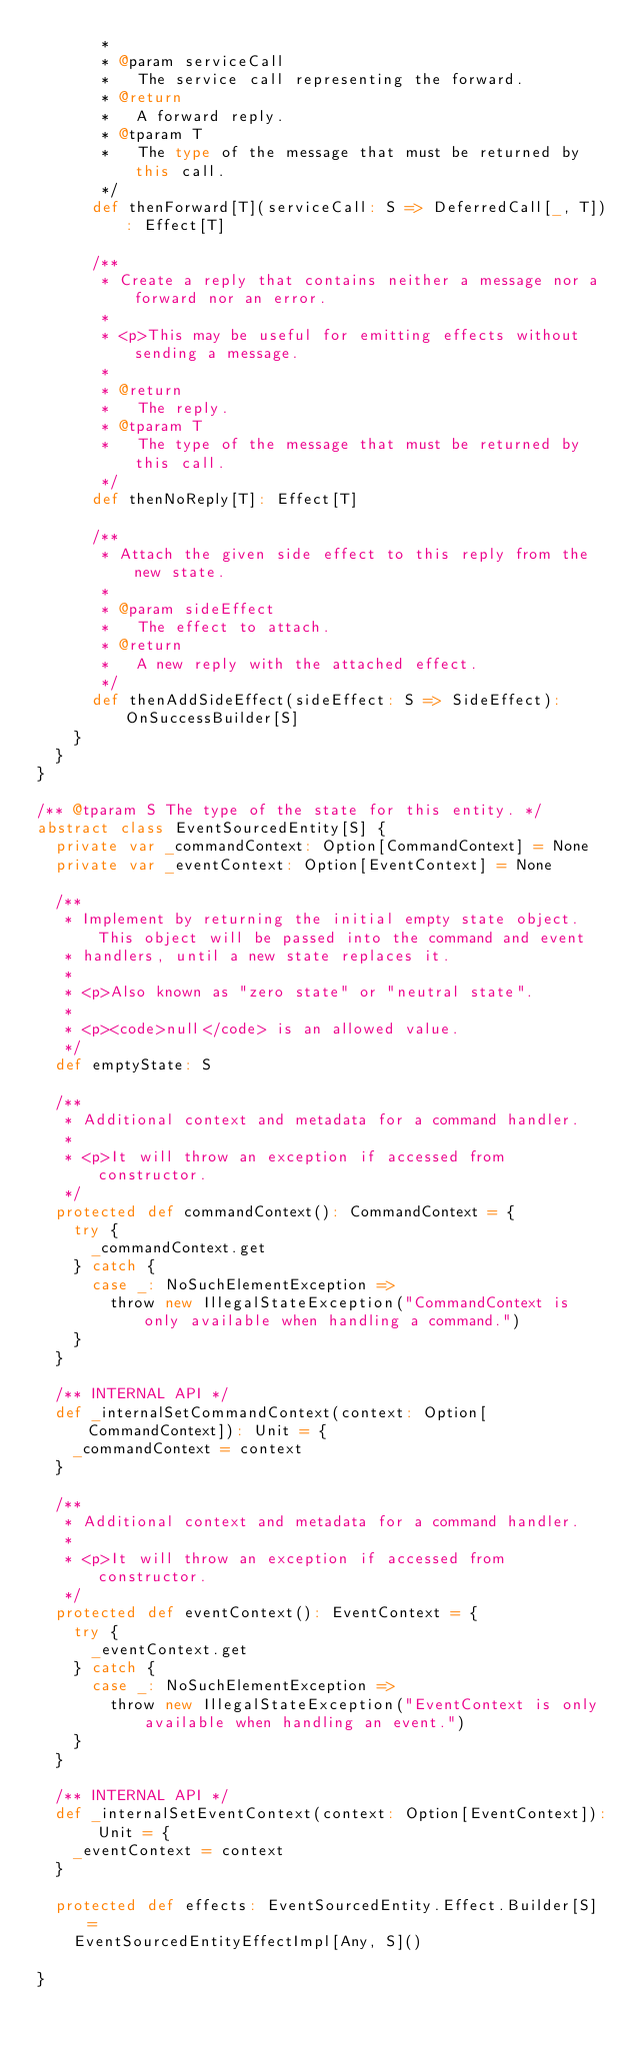<code> <loc_0><loc_0><loc_500><loc_500><_Scala_>       *
       * @param serviceCall
       *   The service call representing the forward.
       * @return
       *   A forward reply.
       * @tparam T
       *   The type of the message that must be returned by this call.
       */
      def thenForward[T](serviceCall: S => DeferredCall[_, T]): Effect[T]

      /**
       * Create a reply that contains neither a message nor a forward nor an error.
       *
       * <p>This may be useful for emitting effects without sending a message.
       *
       * @return
       *   The reply.
       * @tparam T
       *   The type of the message that must be returned by this call.
       */
      def thenNoReply[T]: Effect[T]

      /**
       * Attach the given side effect to this reply from the new state.
       *
       * @param sideEffect
       *   The effect to attach.
       * @return
       *   A new reply with the attached effect.
       */
      def thenAddSideEffect(sideEffect: S => SideEffect): OnSuccessBuilder[S]
    }
  }
}

/** @tparam S The type of the state for this entity. */
abstract class EventSourcedEntity[S] {
  private var _commandContext: Option[CommandContext] = None
  private var _eventContext: Option[EventContext] = None

  /**
   * Implement by returning the initial empty state object. This object will be passed into the command and event
   * handlers, until a new state replaces it.
   *
   * <p>Also known as "zero state" or "neutral state".
   *
   * <p><code>null</code> is an allowed value.
   */
  def emptyState: S

  /**
   * Additional context and metadata for a command handler.
   *
   * <p>It will throw an exception if accessed from constructor.
   */
  protected def commandContext(): CommandContext = {
    try {
      _commandContext.get
    } catch {
      case _: NoSuchElementException =>
        throw new IllegalStateException("CommandContext is only available when handling a command.")
    }
  }

  /** INTERNAL API */
  def _internalSetCommandContext(context: Option[CommandContext]): Unit = {
    _commandContext = context
  }

  /**
   * Additional context and metadata for a command handler.
   *
   * <p>It will throw an exception if accessed from constructor.
   */
  protected def eventContext(): EventContext = {
    try {
      _eventContext.get
    } catch {
      case _: NoSuchElementException =>
        throw new IllegalStateException("EventContext is only available when handling an event.")
    }
  }

  /** INTERNAL API */
  def _internalSetEventContext(context: Option[EventContext]): Unit = {
    _eventContext = context
  }

  protected def effects: EventSourcedEntity.Effect.Builder[S] =
    EventSourcedEntityEffectImpl[Any, S]()

}
</code> 